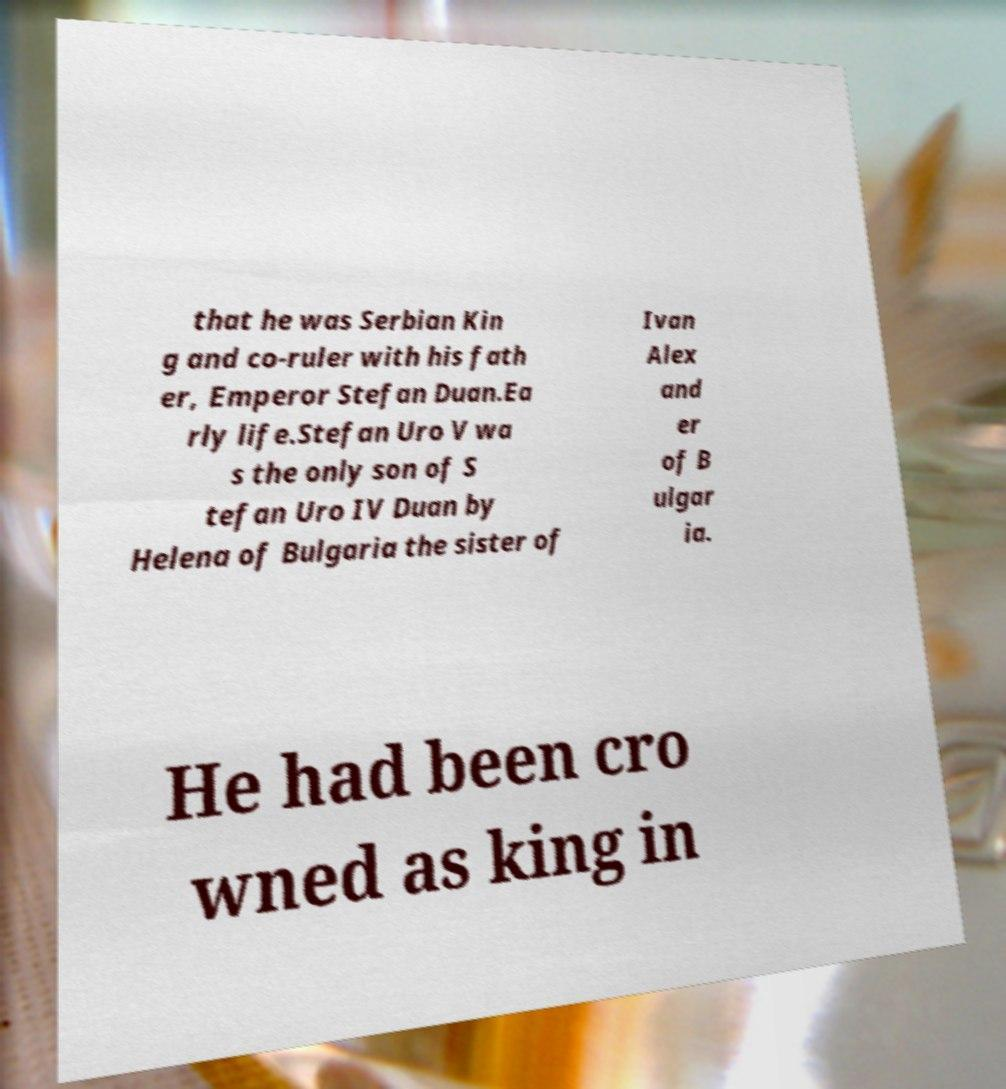There's text embedded in this image that I need extracted. Can you transcribe it verbatim? that he was Serbian Kin g and co-ruler with his fath er, Emperor Stefan Duan.Ea rly life.Stefan Uro V wa s the only son of S tefan Uro IV Duan by Helena of Bulgaria the sister of Ivan Alex and er of B ulgar ia. He had been cro wned as king in 